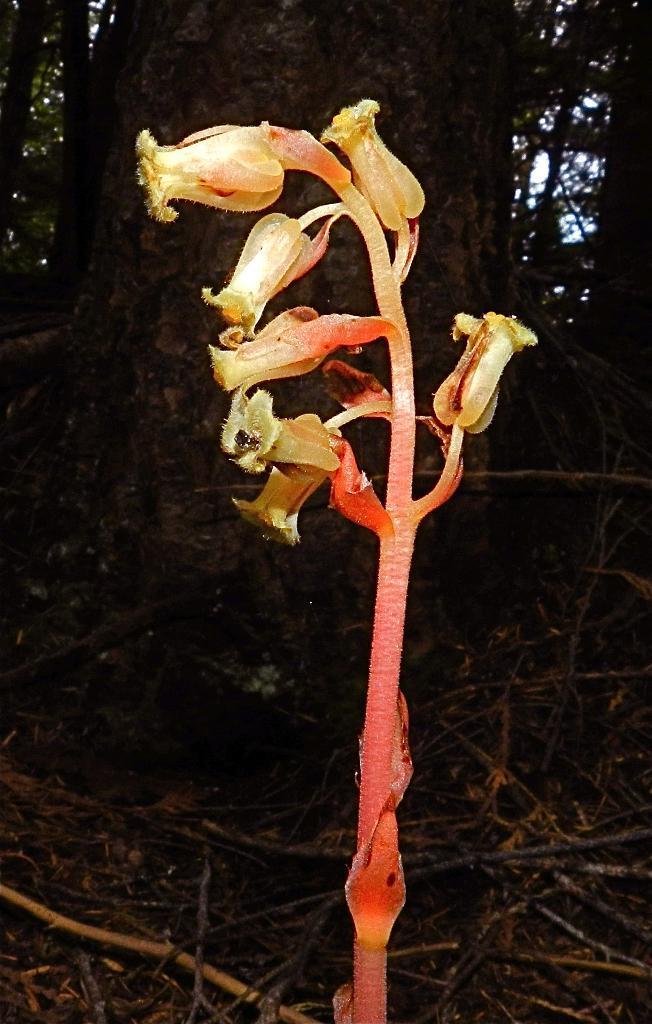How would you summarize this image in a sentence or two? In this picture we can see flowers, sticks and in the background we can see trees. 